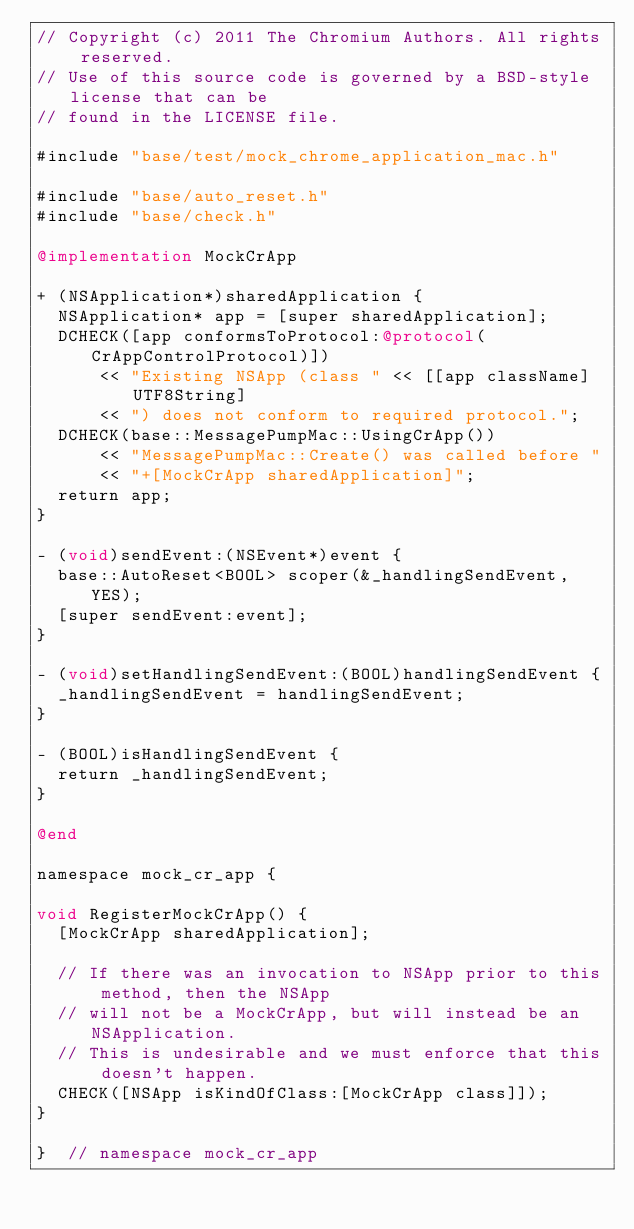Convert code to text. <code><loc_0><loc_0><loc_500><loc_500><_ObjectiveC_>// Copyright (c) 2011 The Chromium Authors. All rights reserved.
// Use of this source code is governed by a BSD-style license that can be
// found in the LICENSE file.

#include "base/test/mock_chrome_application_mac.h"

#include "base/auto_reset.h"
#include "base/check.h"

@implementation MockCrApp

+ (NSApplication*)sharedApplication {
  NSApplication* app = [super sharedApplication];
  DCHECK([app conformsToProtocol:@protocol(CrAppControlProtocol)])
      << "Existing NSApp (class " << [[app className] UTF8String]
      << ") does not conform to required protocol.";
  DCHECK(base::MessagePumpMac::UsingCrApp())
      << "MessagePumpMac::Create() was called before "
      << "+[MockCrApp sharedApplication]";
  return app;
}

- (void)sendEvent:(NSEvent*)event {
  base::AutoReset<BOOL> scoper(&_handlingSendEvent, YES);
  [super sendEvent:event];
}

- (void)setHandlingSendEvent:(BOOL)handlingSendEvent {
  _handlingSendEvent = handlingSendEvent;
}

- (BOOL)isHandlingSendEvent {
  return _handlingSendEvent;
}

@end

namespace mock_cr_app {

void RegisterMockCrApp() {
  [MockCrApp sharedApplication];

  // If there was an invocation to NSApp prior to this method, then the NSApp
  // will not be a MockCrApp, but will instead be an NSApplication.
  // This is undesirable and we must enforce that this doesn't happen.
  CHECK([NSApp isKindOfClass:[MockCrApp class]]);
}

}  // namespace mock_cr_app
</code> 